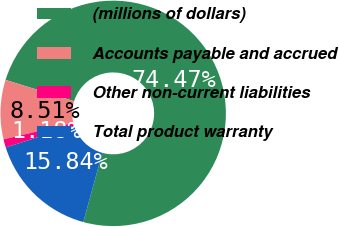Convert chart. <chart><loc_0><loc_0><loc_500><loc_500><pie_chart><fcel>(millions of dollars)<fcel>Accounts payable and accrued<fcel>Other non-current liabilities<fcel>Total product warranty<nl><fcel>74.48%<fcel>8.51%<fcel>1.18%<fcel>15.84%<nl></chart> 